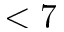<formula> <loc_0><loc_0><loc_500><loc_500>< 7</formula> 